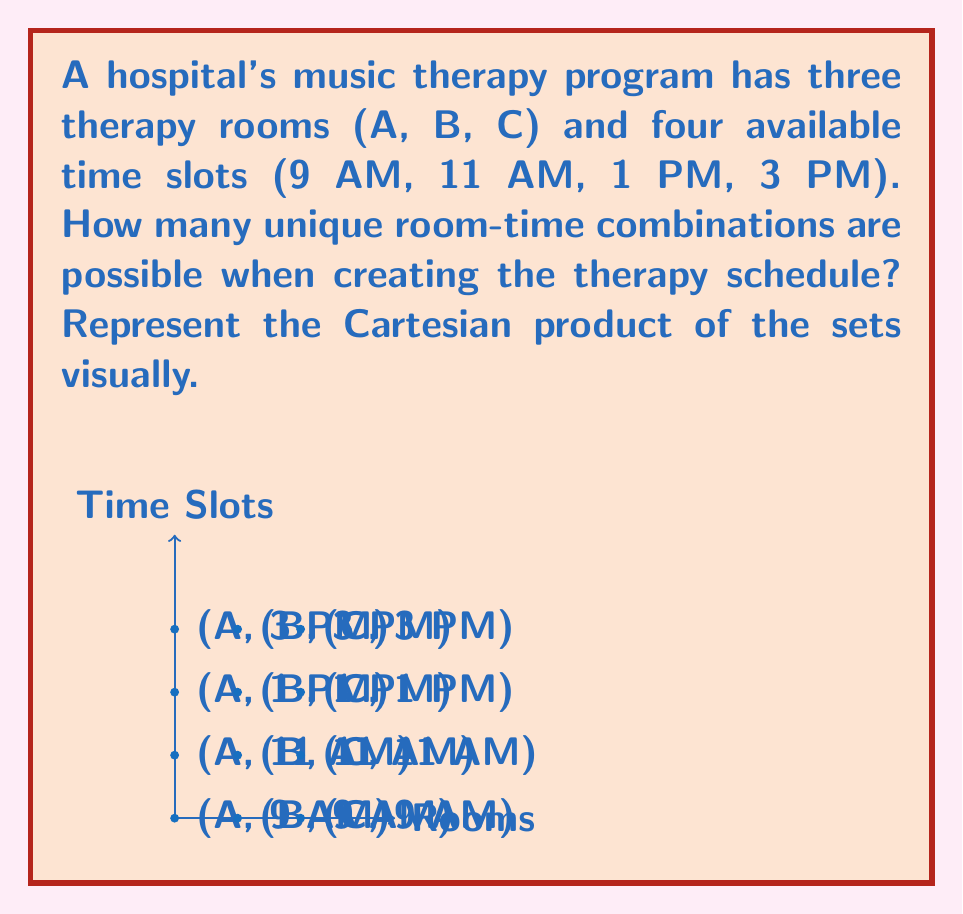Teach me how to tackle this problem. To solve this problem, we need to understand the concept of Cartesian product and apply it to our sets.

1. Define our sets:
   Let $R = \{A, B, C\}$ be the set of therapy rooms
   Let $T = \{9\text{ AM}, 11\text{ AM}, 1\text{ PM}, 3\text{ PM}\}$ be the set of time slots

2. The Cartesian product of these sets, denoted as $R \times T$, is the set of all ordered pairs $(r, t)$ where $r \in R$ and $t \in T$.

3. To calculate the number of elements in the Cartesian product, we use the multiplication principle:
   $|R \times T| = |R| \times |T|$

4. In this case:
   $|R| = 3$ (number of rooms)
   $|T| = 4$ (number of time slots)

5. Therefore:
   $|R \times T| = 3 \times 4 = 12$

The visual representation in the question shows all possible combinations as points on a grid, where each point represents a unique room-time pair.
Answer: 12 unique combinations 